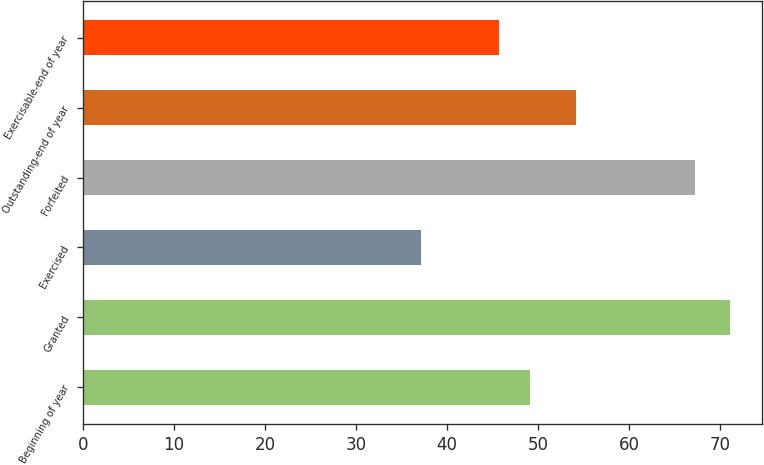<chart> <loc_0><loc_0><loc_500><loc_500><bar_chart><fcel>Beginning of year<fcel>Granted<fcel>Exercised<fcel>Forfeited<fcel>Outstanding-end of year<fcel>Exercisable-end of year<nl><fcel>49.1<fcel>71.12<fcel>37.19<fcel>67.22<fcel>54.17<fcel>45.71<nl></chart> 